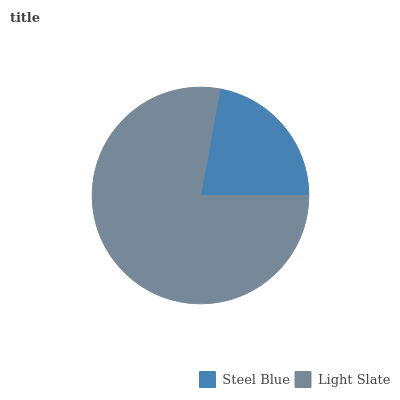Is Steel Blue the minimum?
Answer yes or no. Yes. Is Light Slate the maximum?
Answer yes or no. Yes. Is Light Slate the minimum?
Answer yes or no. No. Is Light Slate greater than Steel Blue?
Answer yes or no. Yes. Is Steel Blue less than Light Slate?
Answer yes or no. Yes. Is Steel Blue greater than Light Slate?
Answer yes or no. No. Is Light Slate less than Steel Blue?
Answer yes or no. No. Is Light Slate the high median?
Answer yes or no. Yes. Is Steel Blue the low median?
Answer yes or no. Yes. Is Steel Blue the high median?
Answer yes or no. No. Is Light Slate the low median?
Answer yes or no. No. 